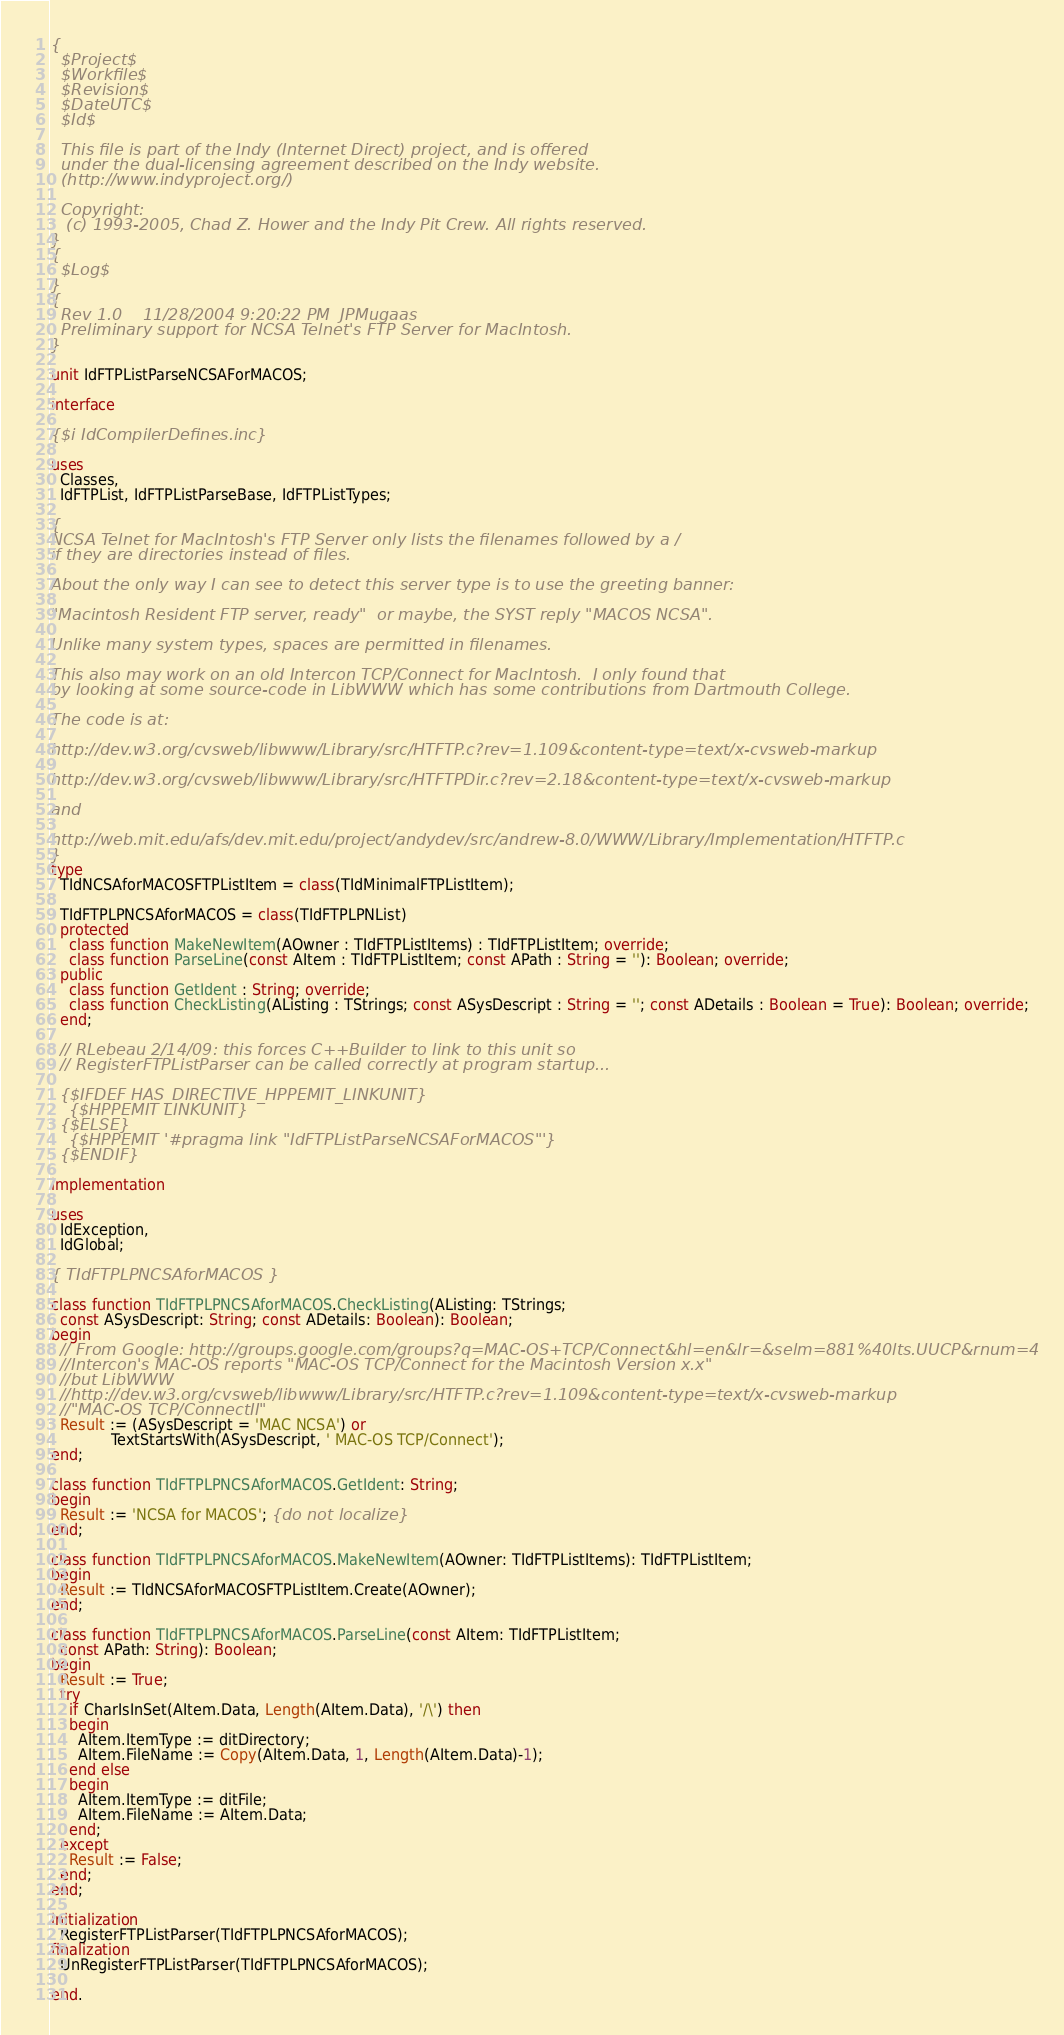Convert code to text. <code><loc_0><loc_0><loc_500><loc_500><_Pascal_>{
  $Project$
  $Workfile$
  $Revision$
  $DateUTC$
  $Id$

  This file is part of the Indy (Internet Direct) project, and is offered
  under the dual-licensing agreement described on the Indy website.
  (http://www.indyproject.org/)

  Copyright:
   (c) 1993-2005, Chad Z. Hower and the Indy Pit Crew. All rights reserved.
}
{
  $Log$
}
{
  Rev 1.0    11/28/2004 9:20:22 PM  JPMugaas
  Preliminary support for NCSA Telnet's FTP Server for MacIntosh.
}

unit IdFTPListParseNCSAForMACOS;

interface

{$i IdCompilerDefines.inc}

uses
  Classes,
  IdFTPList, IdFTPListParseBase, IdFTPListTypes;

{
NCSA Telnet for MacIntosh's FTP Server only lists the filenames followed by a /
if they are directories instead of files.

About the only way I can see to detect this server type is to use the greeting banner:

"Macintosh Resident FTP server, ready"  or maybe, the SYST reply "MACOS NCSA".

Unlike many system types, spaces are permitted in filenames.

This also may work on an old Intercon TCP/Connect for MacIntosh.  I only found that
by looking at some source-code in LibWWW which has some contributions from Dartmouth College.

The code is at:

http://dev.w3.org/cvsweb/libwww/Library/src/HTFTP.c?rev=1.109&content-type=text/x-cvsweb-markup

http://dev.w3.org/cvsweb/libwww/Library/src/HTFTPDir.c?rev=2.18&content-type=text/x-cvsweb-markup

and

http://web.mit.edu/afs/dev.mit.edu/project/andydev/src/andrew-8.0/WWW/Library/Implementation/HTFTP.c
}
type
  TIdNCSAforMACOSFTPListItem = class(TIdMinimalFTPListItem);

  TIdFTPLPNCSAforMACOS = class(TIdFTPLPNList)
  protected
    class function MakeNewItem(AOwner : TIdFTPListItems) : TIdFTPListItem; override;
    class function ParseLine(const AItem : TIdFTPListItem; const APath : String = ''): Boolean; override;
  public
    class function GetIdent : String; override;
    class function CheckListing(AListing : TStrings; const ASysDescript : String = ''; const ADetails : Boolean = True): Boolean; override;
  end;

  // RLebeau 2/14/09: this forces C++Builder to link to this unit so
  // RegisterFTPListParser can be called correctly at program startup...

  {$IFDEF HAS_DIRECTIVE_HPPEMIT_LINKUNIT}
    {$HPPEMIT LINKUNIT}
  {$ELSE}
    {$HPPEMIT '#pragma link "IdFTPListParseNCSAForMACOS"'}
  {$ENDIF}

implementation

uses
  IdException,
  IdGlobal;

{ TIdFTPLPNCSAforMACOS }

class function TIdFTPLPNCSAforMACOS.CheckListing(AListing: TStrings;
  const ASysDescript: String; const ADetails: Boolean): Boolean;
begin
  // From Google: http://groups.google.com/groups?q=MAC-OS+TCP/Connect&hl=en&lr=&selm=881%40lts.UUCP&rnum=4
  //Intercon's MAC-OS reports "MAC-OS TCP/Connect for the Macintosh Version x.x"
  //but LibWWW
  //http://dev.w3.org/cvsweb/libwww/Library/src/HTFTP.c?rev=1.109&content-type=text/x-cvsweb-markup
  //"MAC-OS TCP/ConnectII"
  Result := (ASysDescript = 'MAC NCSA') or
             TextStartsWith(ASysDescript, ' MAC-OS TCP/Connect');
end;

class function TIdFTPLPNCSAforMACOS.GetIdent: String;
begin
  Result := 'NCSA for MACOS'; {do not localize}
end;

class function TIdFTPLPNCSAforMACOS.MakeNewItem(AOwner: TIdFTPListItems): TIdFTPListItem;
begin
  Result := TIdNCSAforMACOSFTPListItem.Create(AOwner);
end;

class function TIdFTPLPNCSAforMACOS.ParseLine(const AItem: TIdFTPListItem;
  const APath: String): Boolean;
begin
  Result := True;
  try
    if CharIsInSet(AItem.Data, Length(AItem.Data), '/\') then
    begin
      AItem.ItemType := ditDirectory;
      AItem.FileName := Copy(AItem.Data, 1, Length(AItem.Data)-1);
    end else
    begin
      AItem.ItemType := ditFile;
      AItem.FileName := AItem.Data;
    end;
  except
    Result := False;
  end;
end;

initialization
  RegisterFTPListParser(TIdFTPLPNCSAforMACOS);
finalization
  UnRegisterFTPListParser(TIdFTPLPNCSAforMACOS);

end.
</code> 